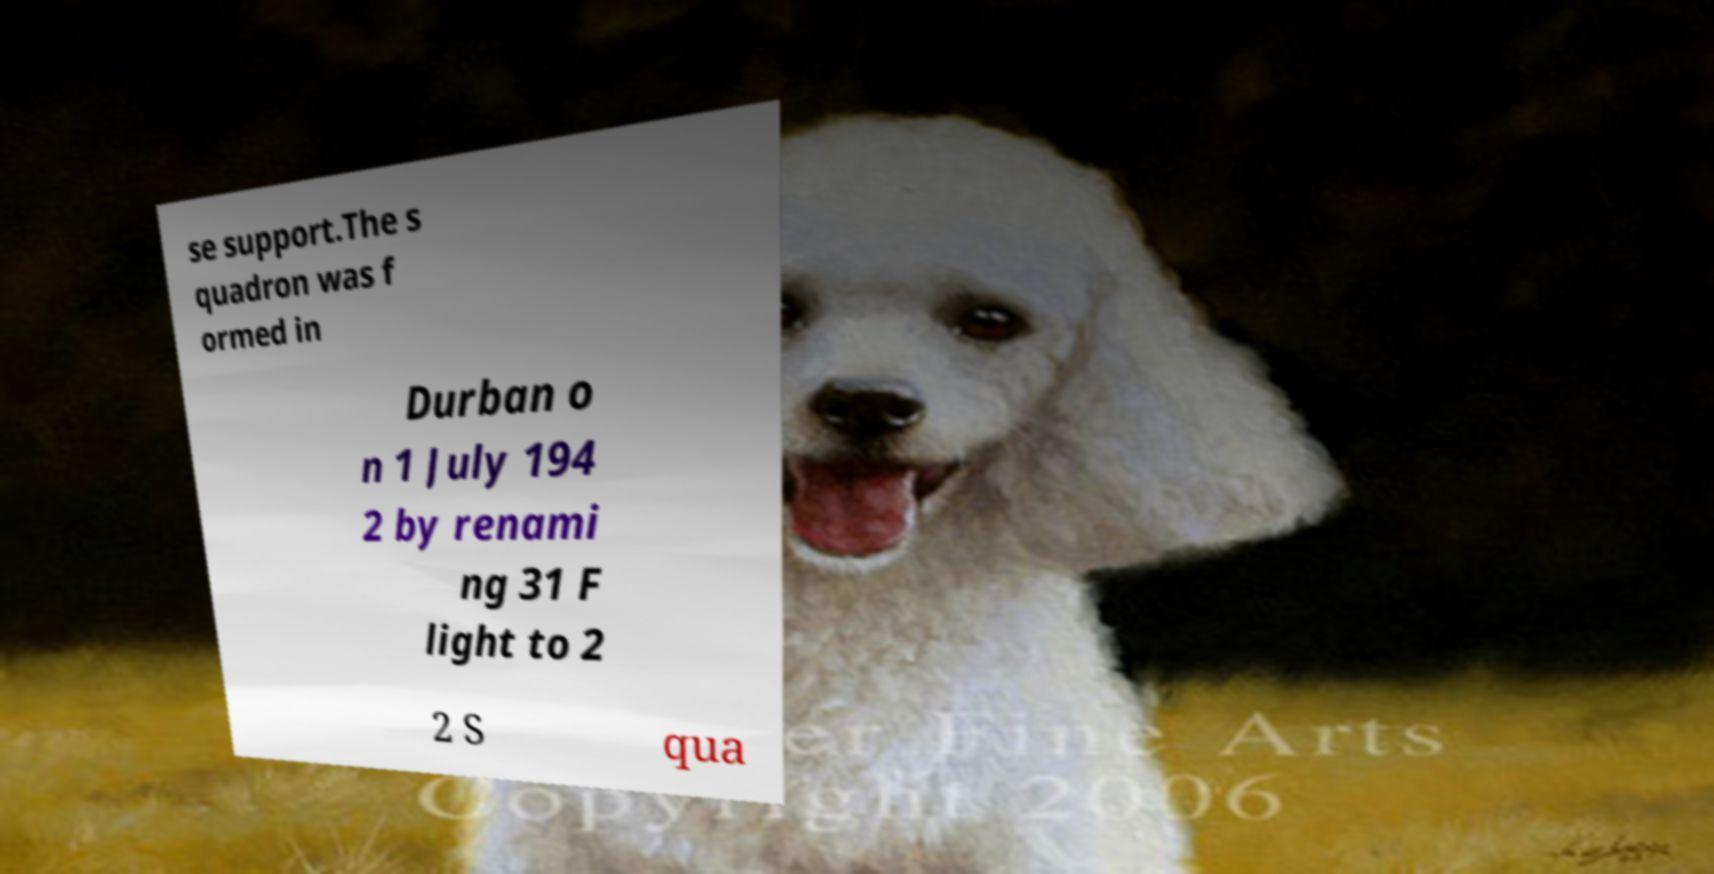Please identify and transcribe the text found in this image. se support.The s quadron was f ormed in Durban o n 1 July 194 2 by renami ng 31 F light to 2 2 S qua 